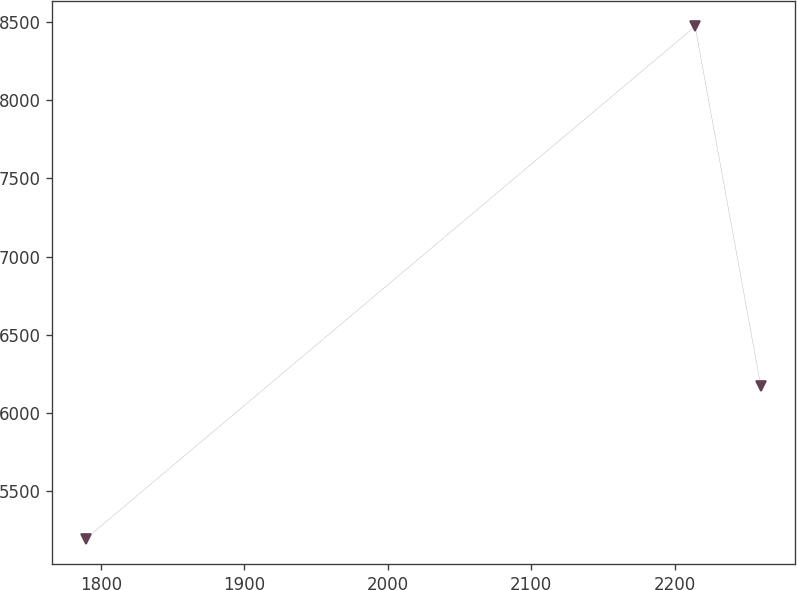<chart> <loc_0><loc_0><loc_500><loc_500><line_chart><ecel><fcel>Unnamed: 1<nl><fcel>1789.78<fcel>5195.17<nl><fcel>2214.36<fcel>8472.9<nl><fcel>2260.19<fcel>6169.03<nl></chart> 